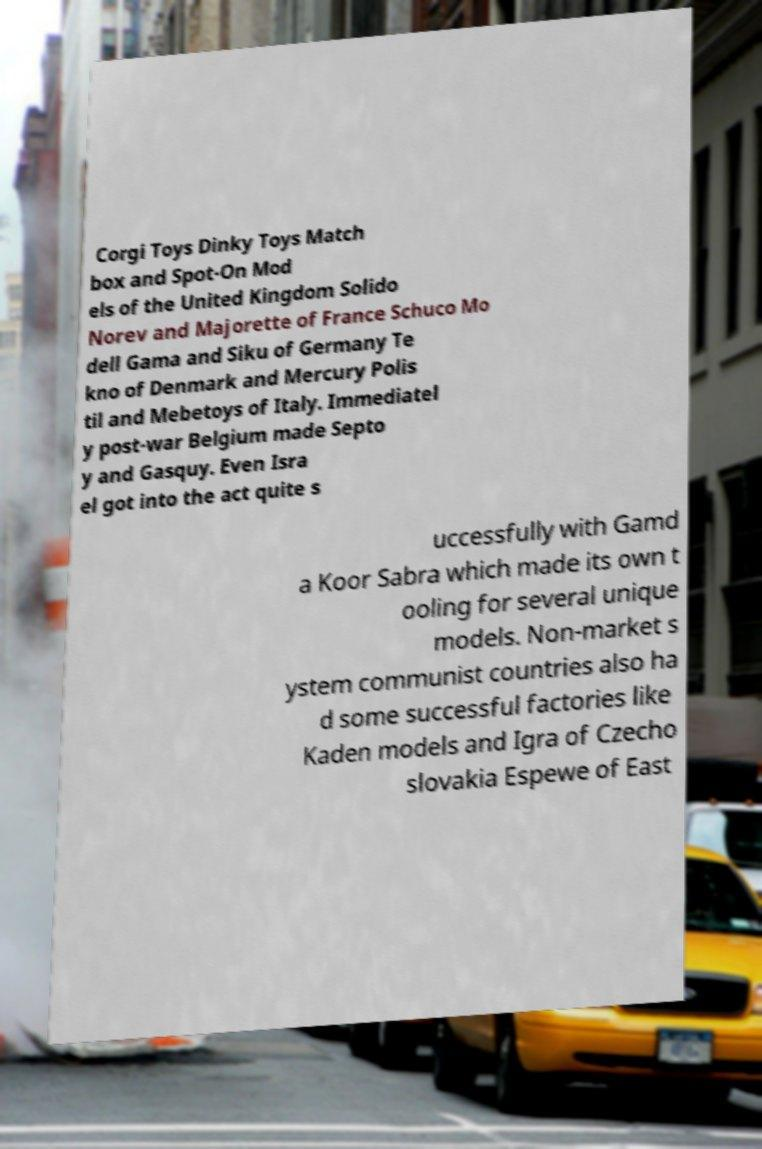Can you accurately transcribe the text from the provided image for me? Corgi Toys Dinky Toys Match box and Spot-On Mod els of the United Kingdom Solido Norev and Majorette of France Schuco Mo dell Gama and Siku of Germany Te kno of Denmark and Mercury Polis til and Mebetoys of Italy. Immediatel y post-war Belgium made Septo y and Gasquy. Even Isra el got into the act quite s uccessfully with Gamd a Koor Sabra which made its own t ooling for several unique models. Non-market s ystem communist countries also ha d some successful factories like Kaden models and Igra of Czecho slovakia Espewe of East 